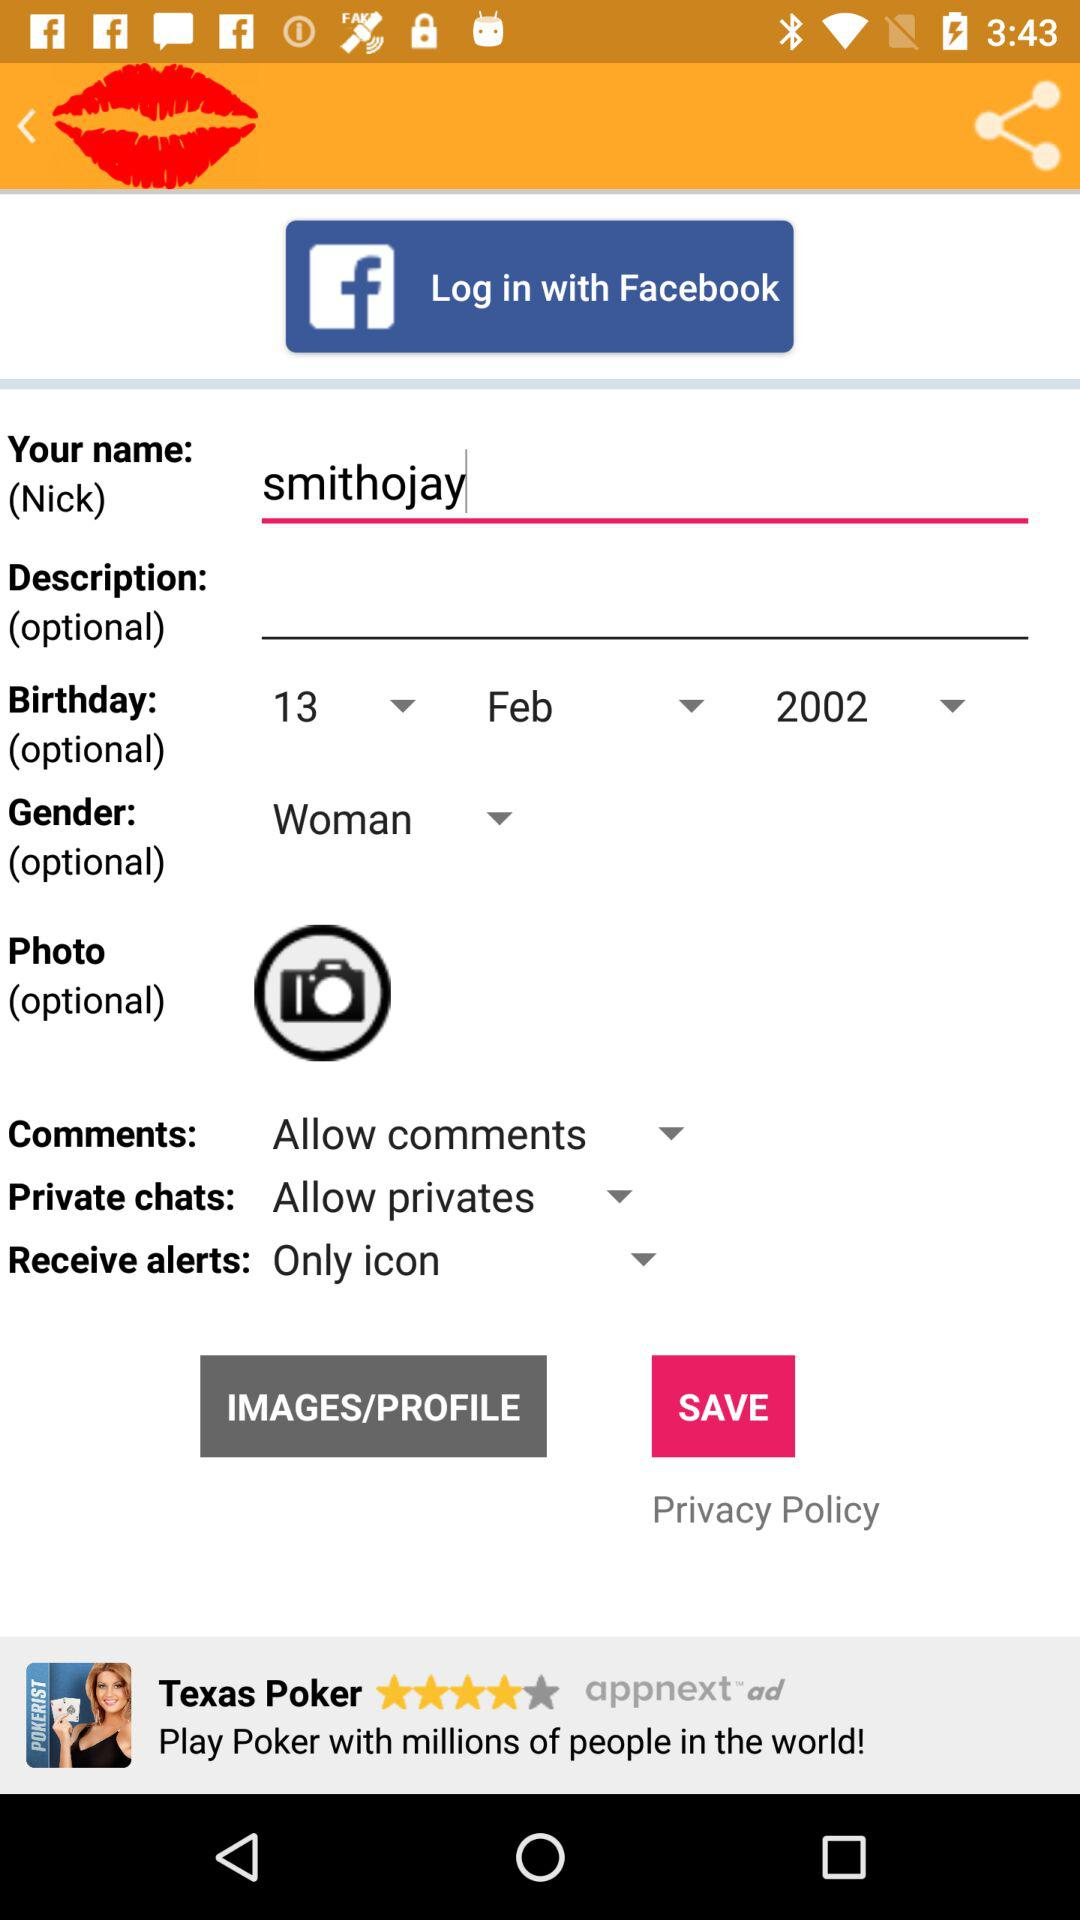What is the gender of the person? The person is a woman. 